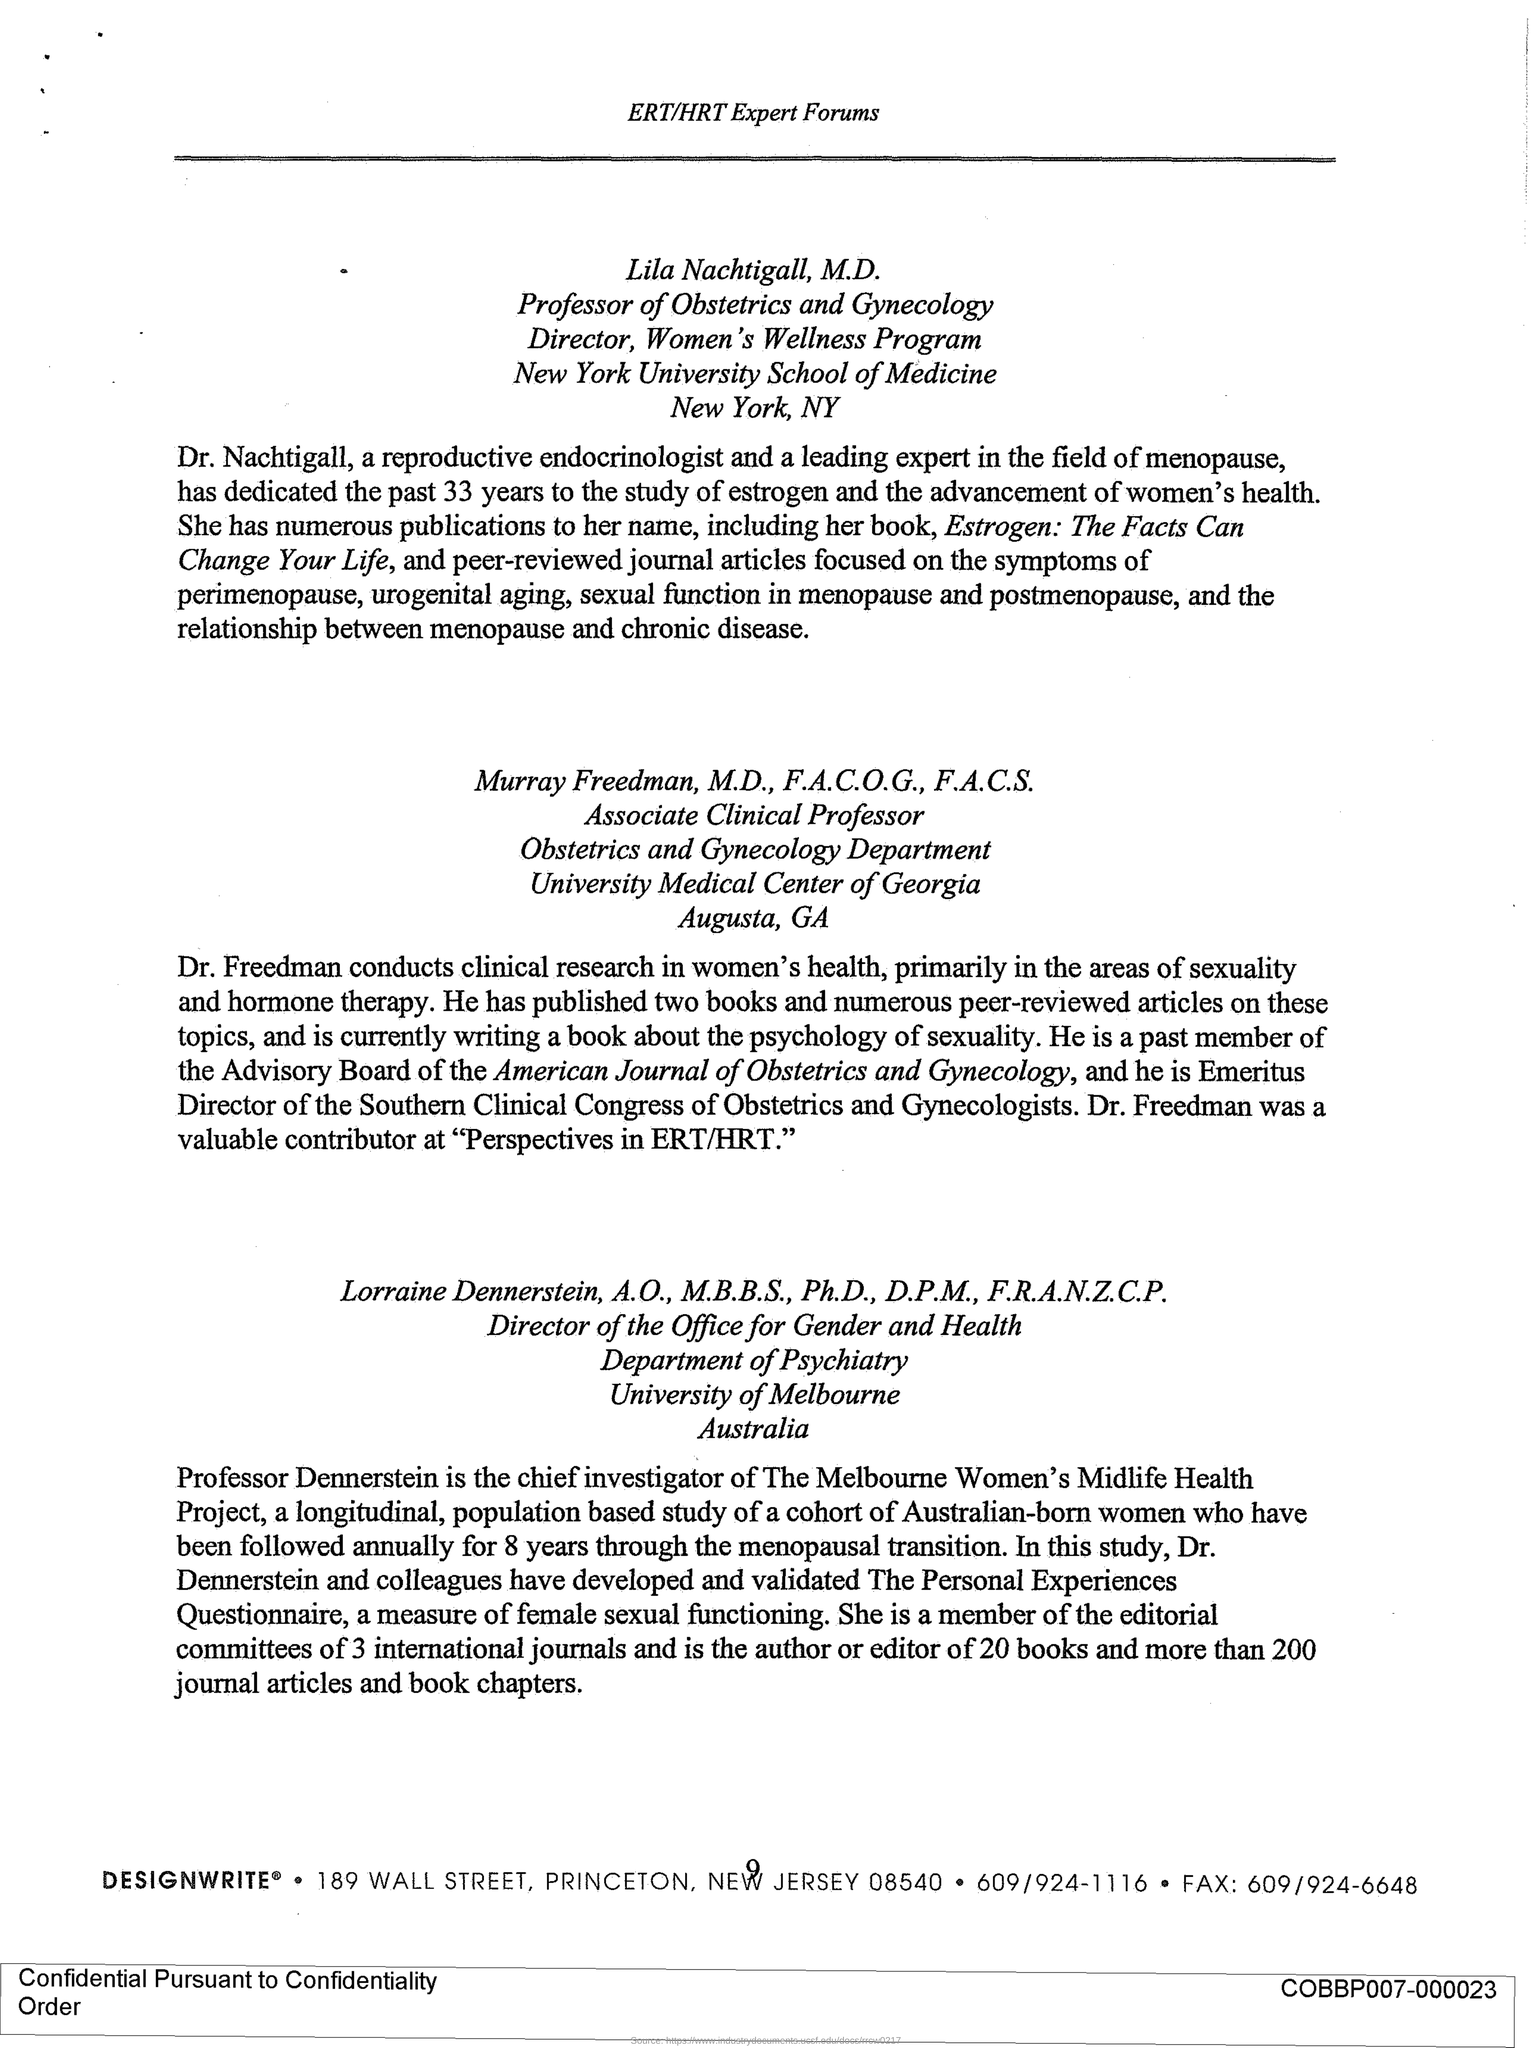List a handful of essential elements in this visual. Murray Freedman holds the designation of an Associate Clinical Professor. Lila Nachtigall holds the designation of Professor of Obstetrics and Gynecology. Lorraine Dennerstein holds the designation of Director of the Office for Gender and Health. 